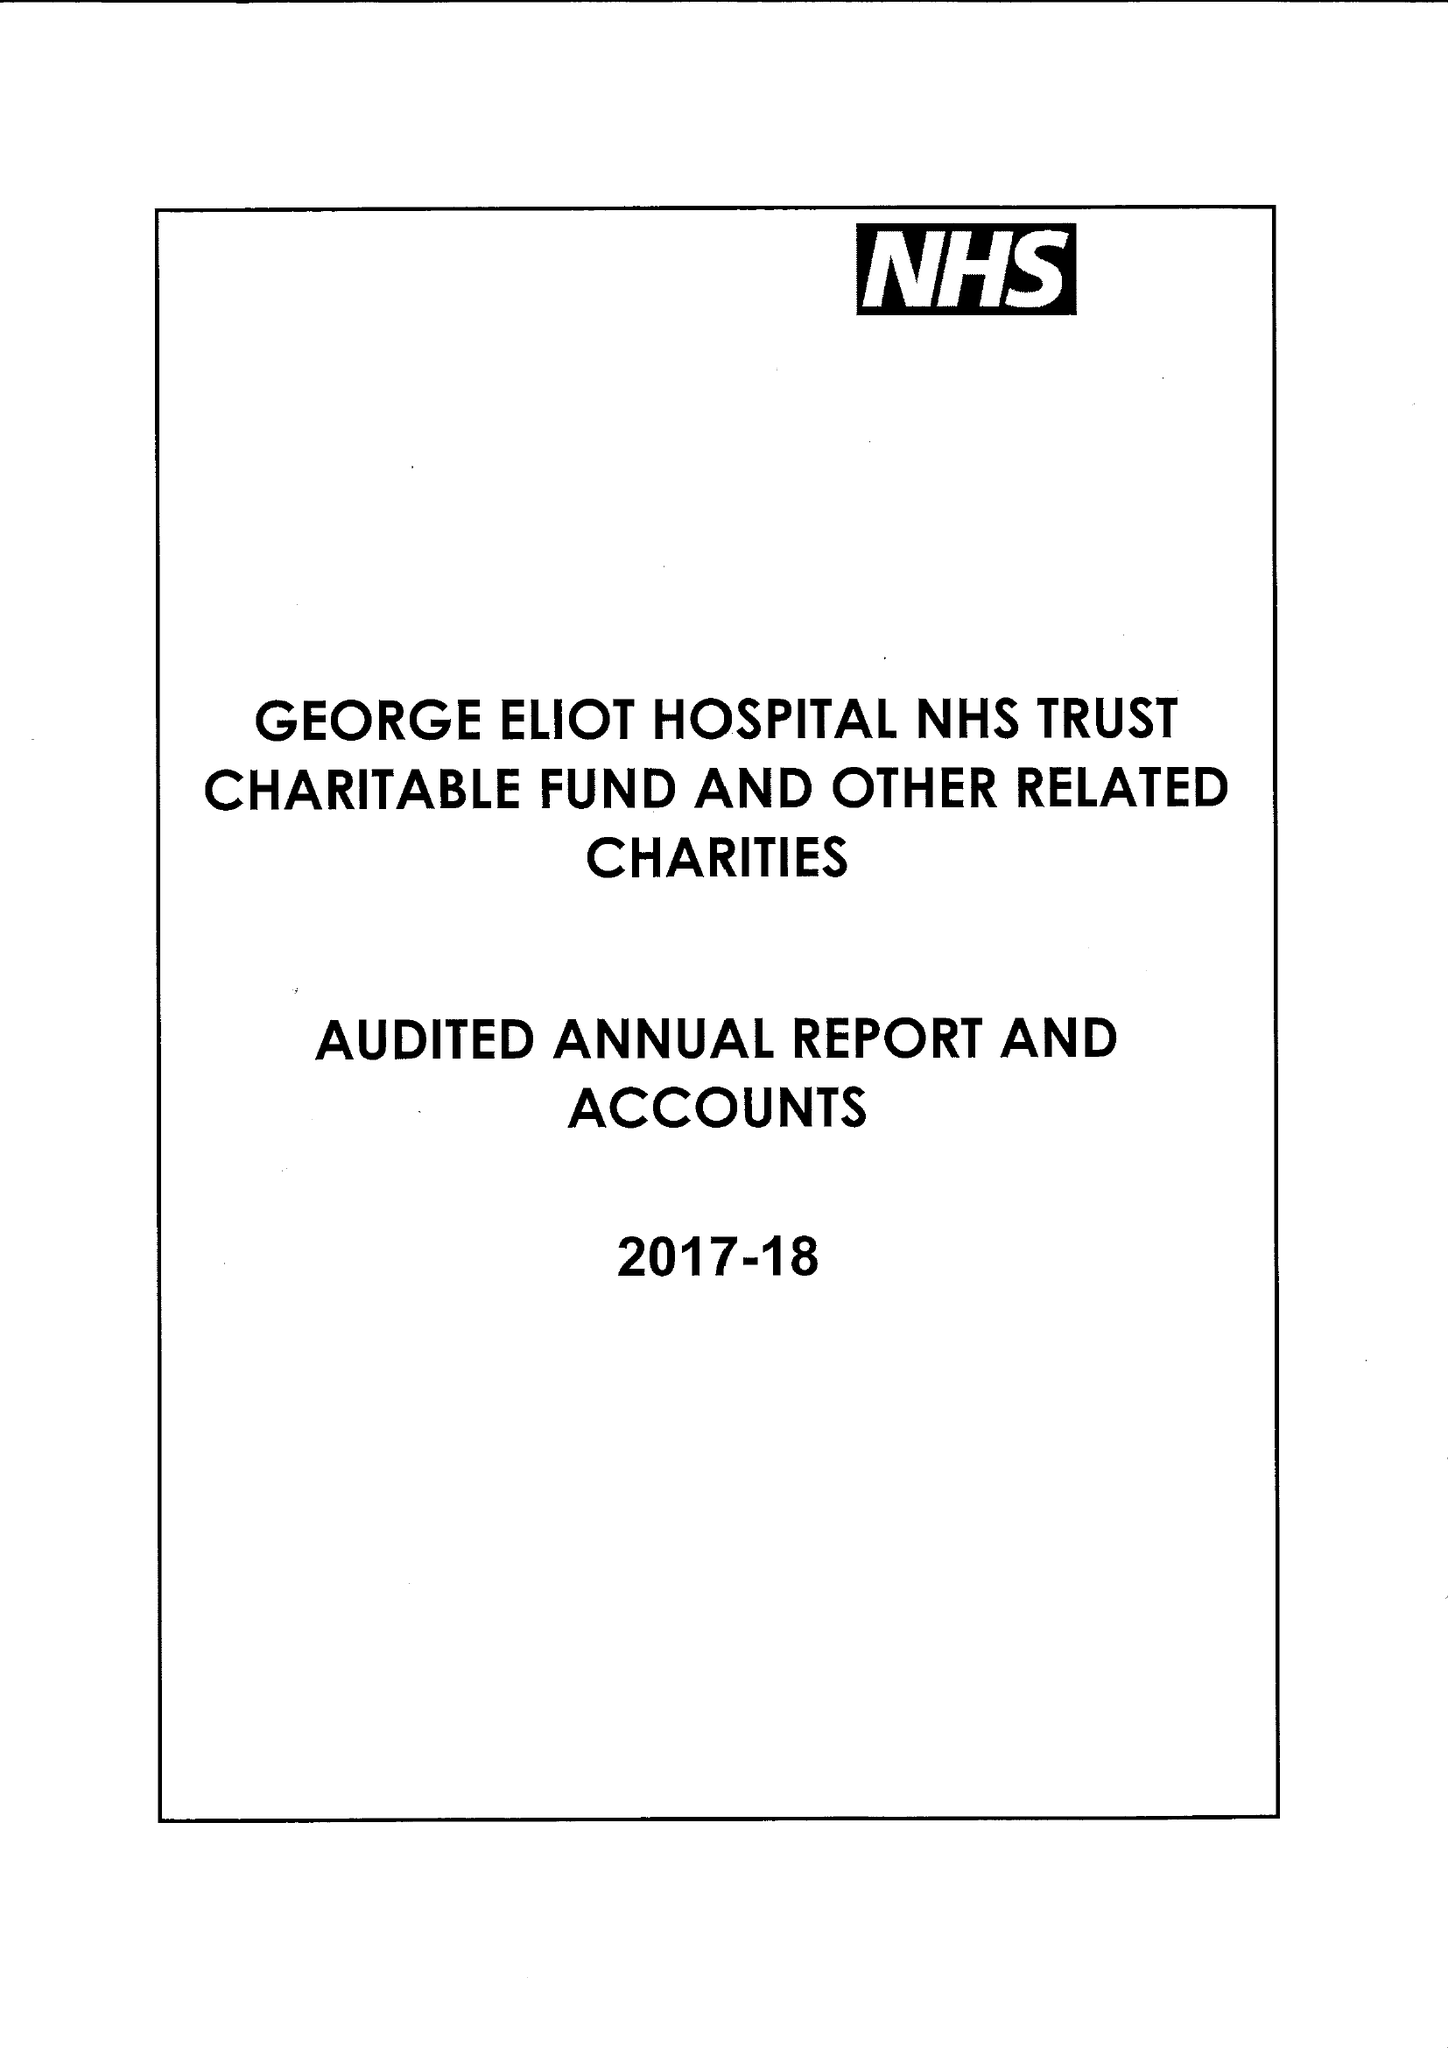What is the value for the spending_annually_in_british_pounds?
Answer the question using a single word or phrase. 202000.00 